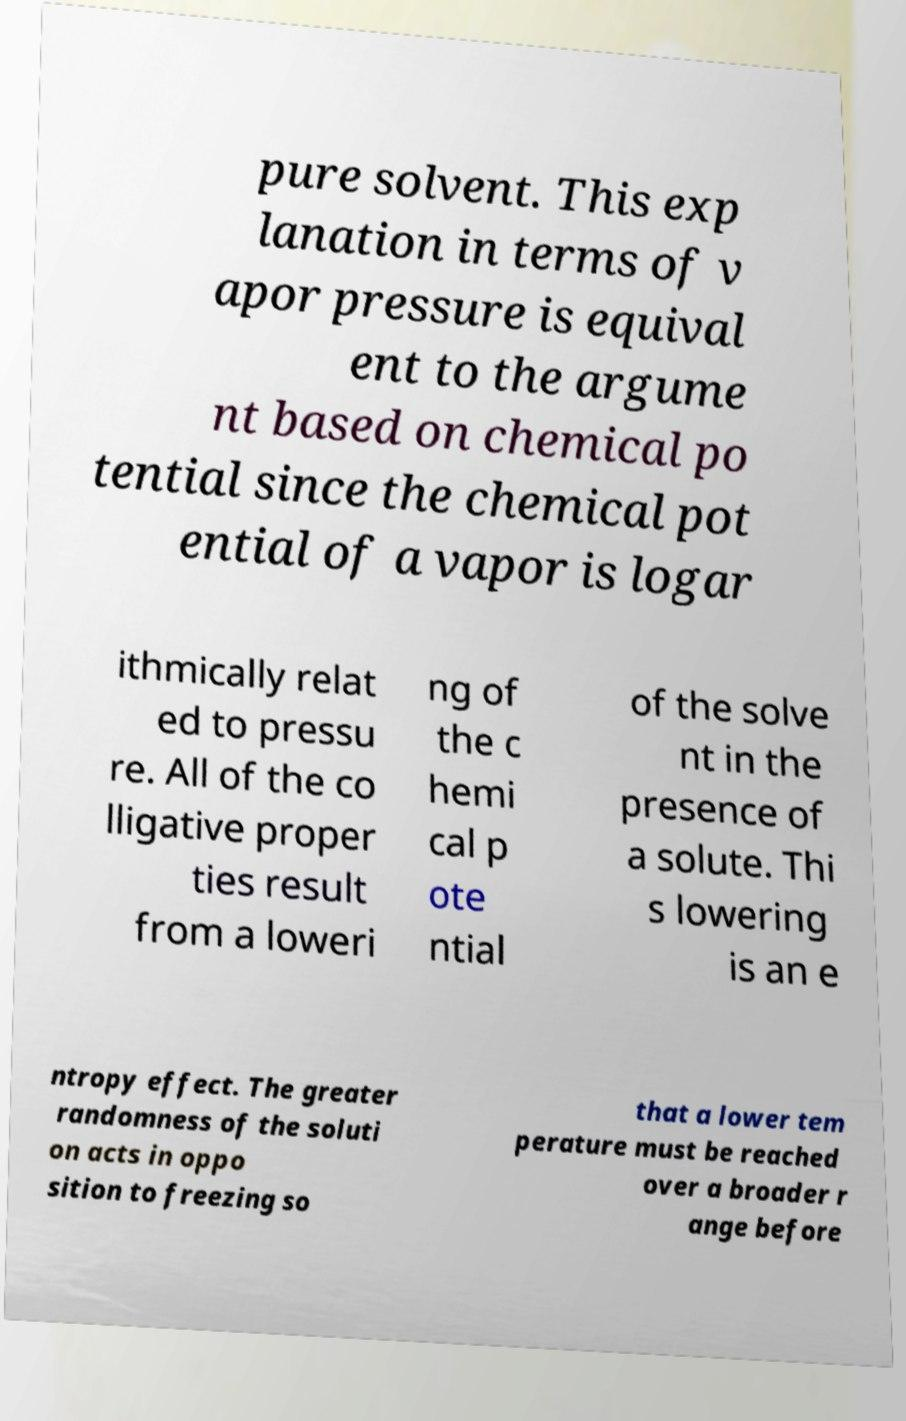Can you accurately transcribe the text from the provided image for me? pure solvent. This exp lanation in terms of v apor pressure is equival ent to the argume nt based on chemical po tential since the chemical pot ential of a vapor is logar ithmically relat ed to pressu re. All of the co lligative proper ties result from a loweri ng of the c hemi cal p ote ntial of the solve nt in the presence of a solute. Thi s lowering is an e ntropy effect. The greater randomness of the soluti on acts in oppo sition to freezing so that a lower tem perature must be reached over a broader r ange before 